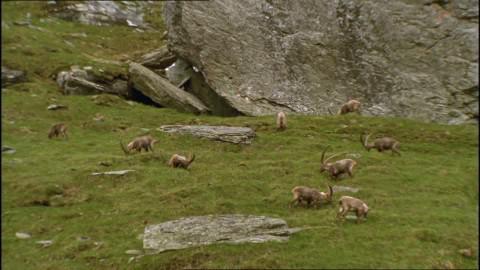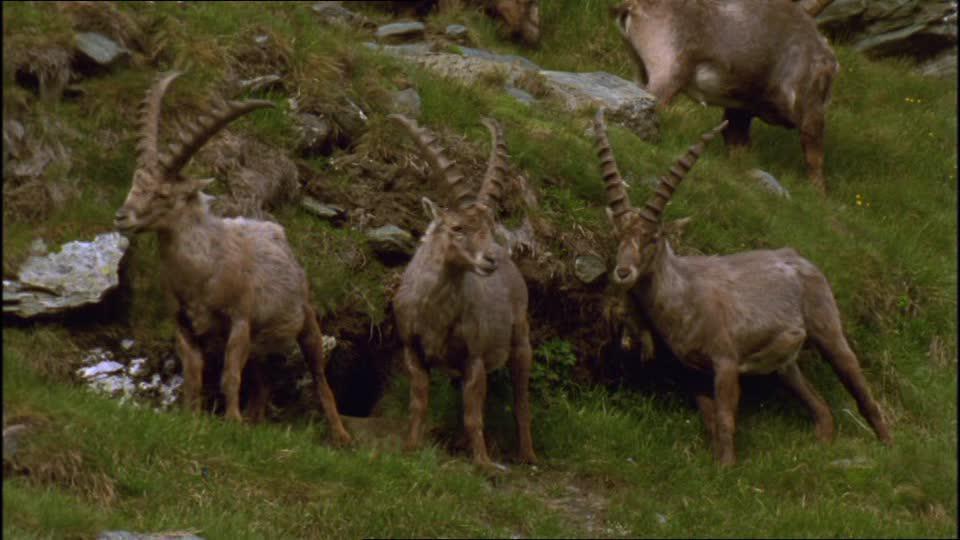The first image is the image on the left, the second image is the image on the right. Analyze the images presented: Is the assertion "Right image shows multiple horned animals grazing, with lowered heads." valid? Answer yes or no. No. The first image is the image on the left, the second image is the image on the right. Examine the images to the left and right. Is the description "There are no rocks near some of the animals." accurate? Answer yes or no. No. 